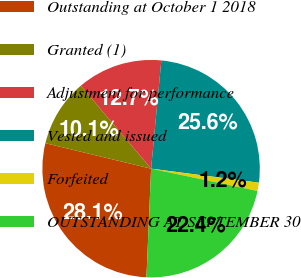Convert chart. <chart><loc_0><loc_0><loc_500><loc_500><pie_chart><fcel>Outstanding at October 1 2018<fcel>Granted (1)<fcel>Adjustment for performance<fcel>Vested and issued<fcel>Forfeited<fcel>OUTSTANDING AT SEPTEMBER 30<nl><fcel>28.08%<fcel>10.05%<fcel>12.69%<fcel>25.56%<fcel>1.23%<fcel>22.39%<nl></chart> 